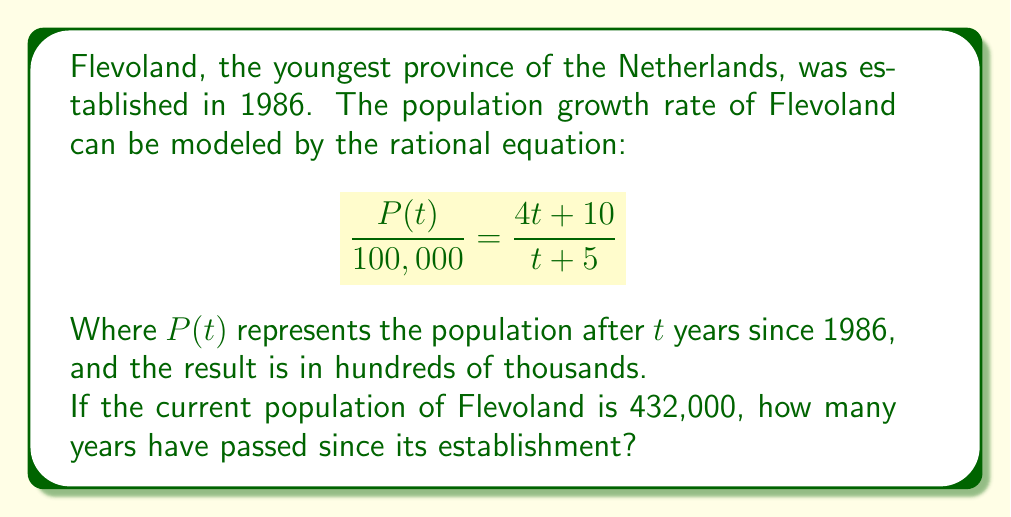What is the answer to this math problem? Let's solve this problem step by step:

1) We're given that the current population is 432,000. Let's substitute this into our equation:

   $$\frac{432,000}{100,000} = \frac{4t + 10}{t + 5}$$

2) Simplify the left side:

   $$4.32 = \frac{4t + 10}{t + 5}$$

3) Multiply both sides by $(t + 5)$:

   $$4.32(t + 5) = 4t + 10$$

4) Distribute on the left side:

   $$4.32t + 21.6 = 4t + 10$$

5) Subtract $4t$ from both sides:

   $$0.32t + 21.6 = 10$$

6) Subtract 21.6 from both sides:

   $$0.32t = -11.6$$

7) Divide both sides by 0.32:

   $$t = -36.25$$

8) Since time can't be negative, and we're looking for years since 1986, we need to add 36.25 to the current year (2023):

   $$2023 + 36.25 = 2059.25$$

9) Round down to the nearest whole year:

   $$2059 - 1986 = 73$$

Therefore, 73 years have passed since the establishment of Flevoland in this model.
Answer: 73 years 